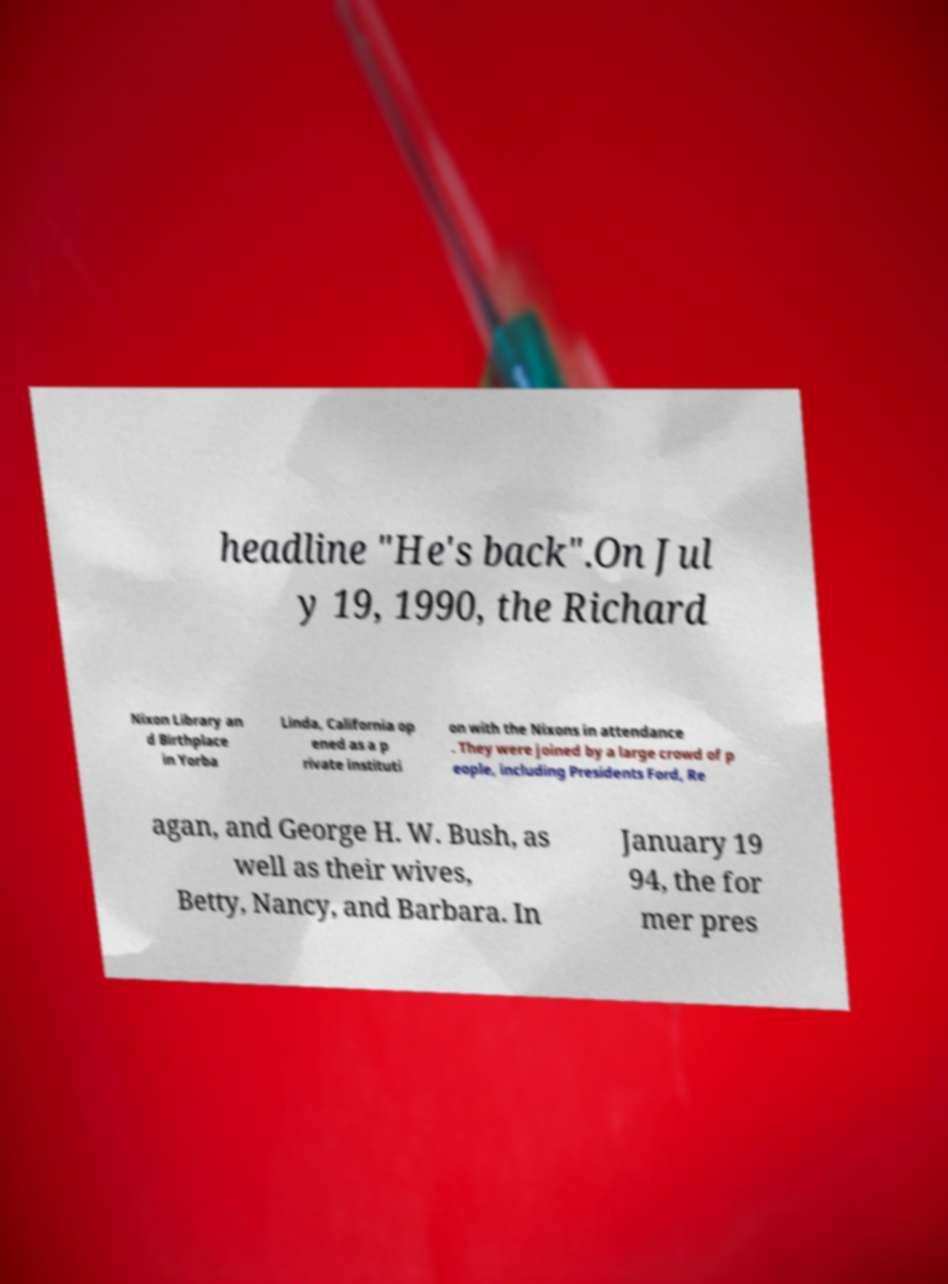I need the written content from this picture converted into text. Can you do that? headline "He's back".On Jul y 19, 1990, the Richard Nixon Library an d Birthplace in Yorba Linda, California op ened as a p rivate instituti on with the Nixons in attendance . They were joined by a large crowd of p eople, including Presidents Ford, Re agan, and George H. W. Bush, as well as their wives, Betty, Nancy, and Barbara. In January 19 94, the for mer pres 